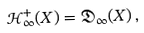<formula> <loc_0><loc_0><loc_500><loc_500>\mathcal { H } ^ { + } _ { \infty } ( X ) = \mathfrak { D } _ { \infty } ( X ) \, ,</formula> 